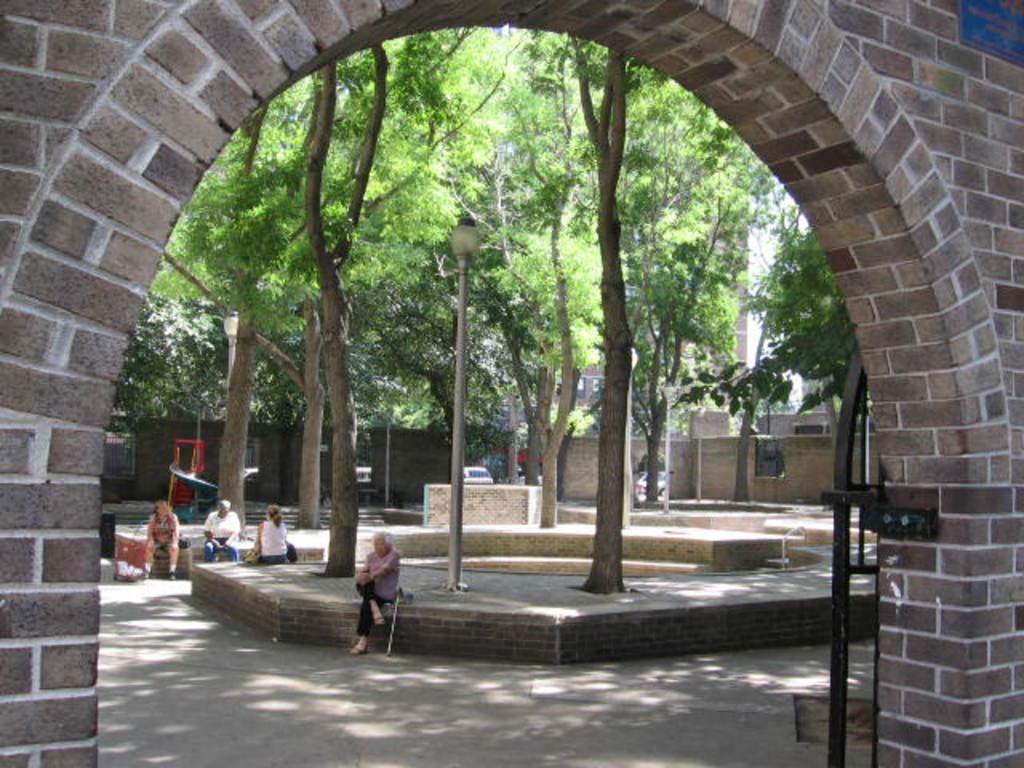Describe this image in one or two sentences. In this image we can see an arch. Image also consists of four people sitting. We can also see many trees, buildings and also light poles. Path is also visible. 